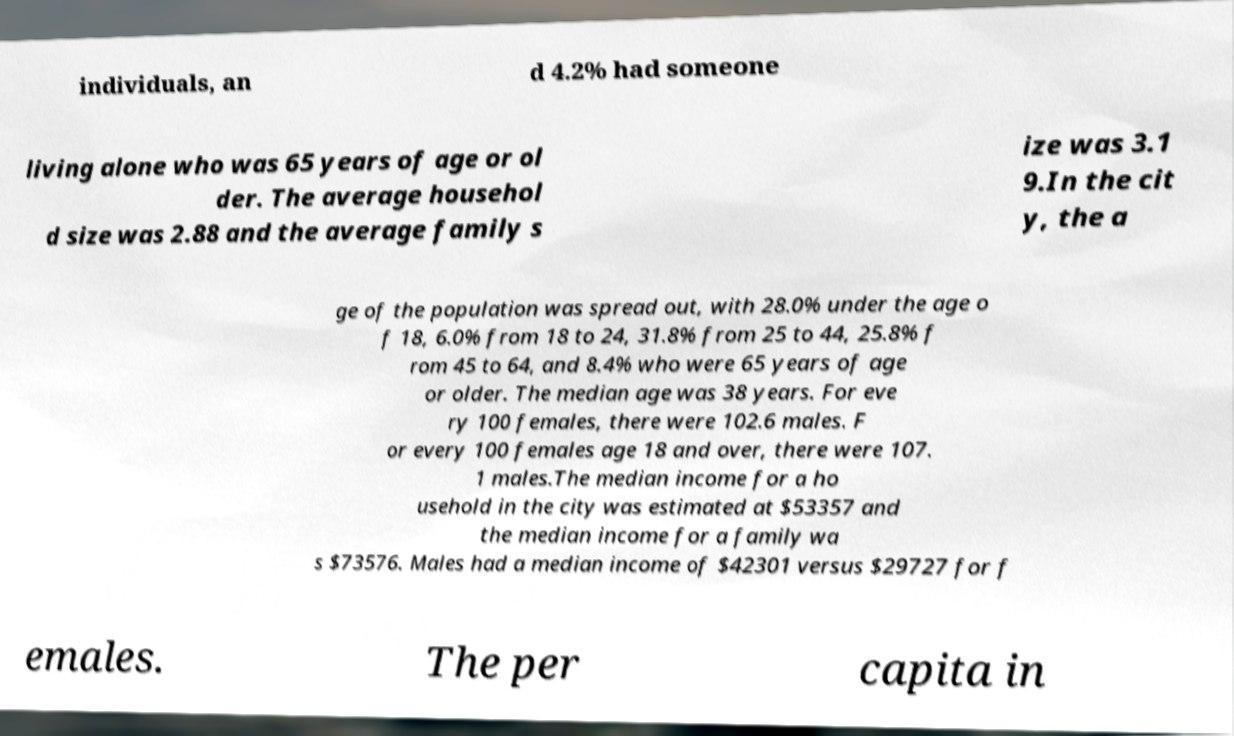Can you read and provide the text displayed in the image?This photo seems to have some interesting text. Can you extract and type it out for me? individuals, an d 4.2% had someone living alone who was 65 years of age or ol der. The average househol d size was 2.88 and the average family s ize was 3.1 9.In the cit y, the a ge of the population was spread out, with 28.0% under the age o f 18, 6.0% from 18 to 24, 31.8% from 25 to 44, 25.8% f rom 45 to 64, and 8.4% who were 65 years of age or older. The median age was 38 years. For eve ry 100 females, there were 102.6 males. F or every 100 females age 18 and over, there were 107. 1 males.The median income for a ho usehold in the city was estimated at $53357 and the median income for a family wa s $73576. Males had a median income of $42301 versus $29727 for f emales. The per capita in 